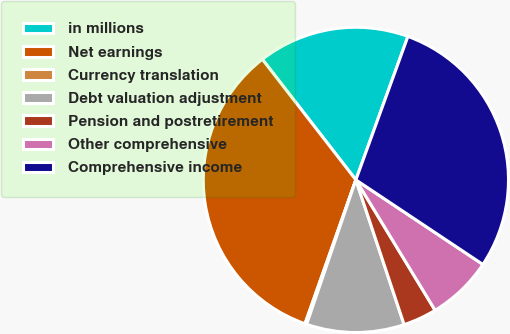Convert chart. <chart><loc_0><loc_0><loc_500><loc_500><pie_chart><fcel>in millions<fcel>Net earnings<fcel>Currency translation<fcel>Debt valuation adjustment<fcel>Pension and postretirement<fcel>Other comprehensive<fcel>Comprehensive income<nl><fcel>16.04%<fcel>34.09%<fcel>0.18%<fcel>10.35%<fcel>3.57%<fcel>6.96%<fcel>28.81%<nl></chart> 